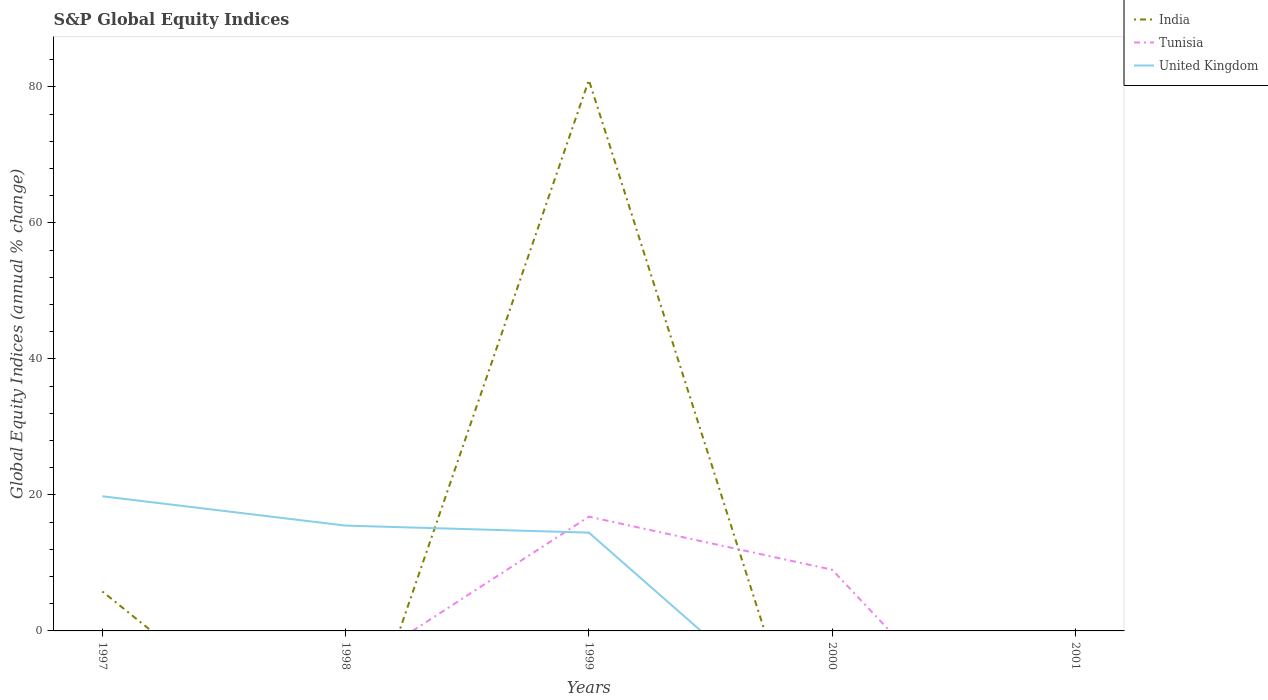Is the number of lines equal to the number of legend labels?
Keep it short and to the point. No. What is the total global equity indices in United Kingdom in the graph?
Ensure brevity in your answer.  4.31. What is the difference between the highest and the lowest global equity indices in India?
Make the answer very short. 1. How many lines are there?
Your answer should be very brief. 3. Does the graph contain any zero values?
Provide a succinct answer. Yes. How many legend labels are there?
Provide a short and direct response. 3. What is the title of the graph?
Give a very brief answer. S&P Global Equity Indices. What is the label or title of the X-axis?
Offer a terse response. Years. What is the label or title of the Y-axis?
Provide a short and direct response. Global Equity Indices (annual % change). What is the Global Equity Indices (annual % change) of India in 1997?
Keep it short and to the point. 5.8. What is the Global Equity Indices (annual % change) in Tunisia in 1997?
Make the answer very short. 0. What is the Global Equity Indices (annual % change) in United Kingdom in 1997?
Offer a very short reply. 19.8. What is the Global Equity Indices (annual % change) in Tunisia in 1998?
Provide a succinct answer. 0. What is the Global Equity Indices (annual % change) in United Kingdom in 1998?
Keep it short and to the point. 15.49. What is the Global Equity Indices (annual % change) in Tunisia in 1999?
Provide a succinct answer. 16.8. What is the Global Equity Indices (annual % change) of United Kingdom in 1999?
Your answer should be very brief. 14.45. What is the Global Equity Indices (annual % change) of India in 2000?
Offer a very short reply. 0. What is the Global Equity Indices (annual % change) of Tunisia in 2000?
Your answer should be very brief. 9. What is the Global Equity Indices (annual % change) of United Kingdom in 2000?
Keep it short and to the point. 0. What is the Global Equity Indices (annual % change) in India in 2001?
Give a very brief answer. 0. What is the Global Equity Indices (annual % change) in United Kingdom in 2001?
Your answer should be compact. 0. Across all years, what is the maximum Global Equity Indices (annual % change) in Tunisia?
Your response must be concise. 16.8. Across all years, what is the maximum Global Equity Indices (annual % change) of United Kingdom?
Offer a very short reply. 19.8. Across all years, what is the minimum Global Equity Indices (annual % change) in Tunisia?
Provide a succinct answer. 0. Across all years, what is the minimum Global Equity Indices (annual % change) in United Kingdom?
Your answer should be compact. 0. What is the total Global Equity Indices (annual % change) of India in the graph?
Your response must be concise. 86.8. What is the total Global Equity Indices (annual % change) of Tunisia in the graph?
Make the answer very short. 25.8. What is the total Global Equity Indices (annual % change) in United Kingdom in the graph?
Your answer should be very brief. 49.74. What is the difference between the Global Equity Indices (annual % change) in United Kingdom in 1997 and that in 1998?
Your answer should be compact. 4.32. What is the difference between the Global Equity Indices (annual % change) in India in 1997 and that in 1999?
Make the answer very short. -75.2. What is the difference between the Global Equity Indices (annual % change) of United Kingdom in 1997 and that in 1999?
Your answer should be compact. 5.35. What is the difference between the Global Equity Indices (annual % change) of United Kingdom in 1998 and that in 1999?
Provide a short and direct response. 1.03. What is the difference between the Global Equity Indices (annual % change) in Tunisia in 1999 and that in 2000?
Ensure brevity in your answer.  7.8. What is the difference between the Global Equity Indices (annual % change) in India in 1997 and the Global Equity Indices (annual % change) in United Kingdom in 1998?
Your response must be concise. -9.69. What is the difference between the Global Equity Indices (annual % change) in India in 1997 and the Global Equity Indices (annual % change) in Tunisia in 1999?
Give a very brief answer. -11. What is the difference between the Global Equity Indices (annual % change) in India in 1997 and the Global Equity Indices (annual % change) in United Kingdom in 1999?
Your response must be concise. -8.65. What is the difference between the Global Equity Indices (annual % change) in India in 1997 and the Global Equity Indices (annual % change) in Tunisia in 2000?
Provide a short and direct response. -3.2. What is the difference between the Global Equity Indices (annual % change) of India in 1999 and the Global Equity Indices (annual % change) of Tunisia in 2000?
Offer a terse response. 72. What is the average Global Equity Indices (annual % change) in India per year?
Make the answer very short. 17.36. What is the average Global Equity Indices (annual % change) of Tunisia per year?
Ensure brevity in your answer.  5.16. What is the average Global Equity Indices (annual % change) of United Kingdom per year?
Provide a succinct answer. 9.95. In the year 1997, what is the difference between the Global Equity Indices (annual % change) in India and Global Equity Indices (annual % change) in United Kingdom?
Your response must be concise. -14. In the year 1999, what is the difference between the Global Equity Indices (annual % change) in India and Global Equity Indices (annual % change) in Tunisia?
Keep it short and to the point. 64.2. In the year 1999, what is the difference between the Global Equity Indices (annual % change) of India and Global Equity Indices (annual % change) of United Kingdom?
Offer a terse response. 66.55. In the year 1999, what is the difference between the Global Equity Indices (annual % change) of Tunisia and Global Equity Indices (annual % change) of United Kingdom?
Your response must be concise. 2.35. What is the ratio of the Global Equity Indices (annual % change) in United Kingdom in 1997 to that in 1998?
Ensure brevity in your answer.  1.28. What is the ratio of the Global Equity Indices (annual % change) of India in 1997 to that in 1999?
Keep it short and to the point. 0.07. What is the ratio of the Global Equity Indices (annual % change) in United Kingdom in 1997 to that in 1999?
Give a very brief answer. 1.37. What is the ratio of the Global Equity Indices (annual % change) in United Kingdom in 1998 to that in 1999?
Offer a terse response. 1.07. What is the ratio of the Global Equity Indices (annual % change) of Tunisia in 1999 to that in 2000?
Offer a terse response. 1.87. What is the difference between the highest and the second highest Global Equity Indices (annual % change) of United Kingdom?
Keep it short and to the point. 4.32. What is the difference between the highest and the lowest Global Equity Indices (annual % change) in India?
Make the answer very short. 81. What is the difference between the highest and the lowest Global Equity Indices (annual % change) of United Kingdom?
Make the answer very short. 19.8. 